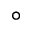Convert formula to latex. <formula><loc_0><loc_0><loc_500><loc_500>^ { \circ }</formula> 